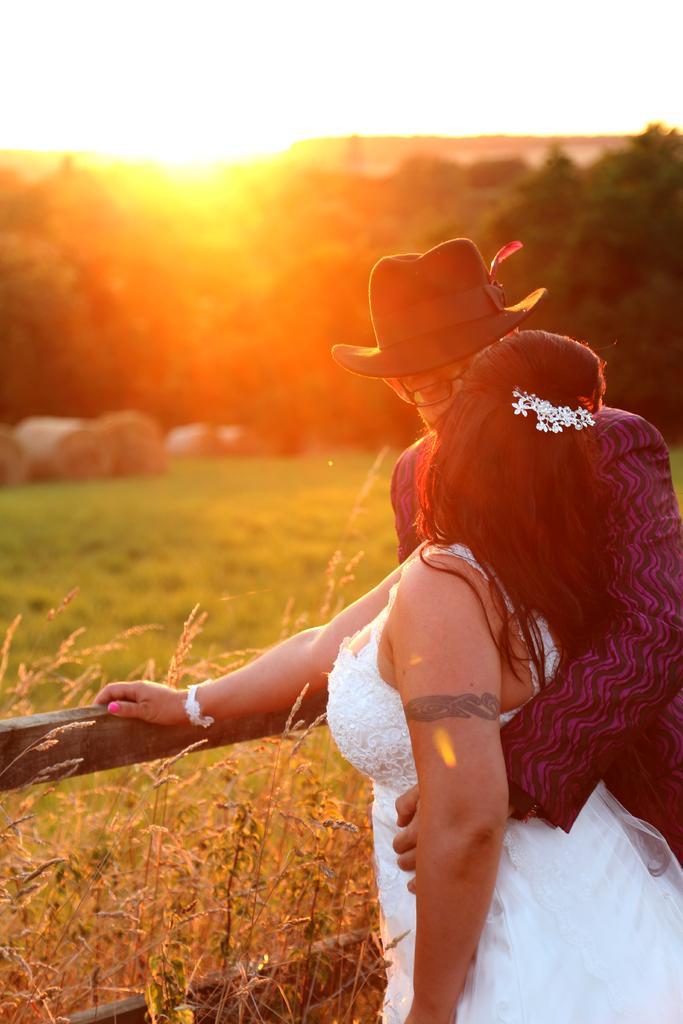How would you summarize this image in a sentence or two? In the foreground of the picture there are plants, railing and two persons standing. The background is blurred. In the background there are trees, grass and sun. 